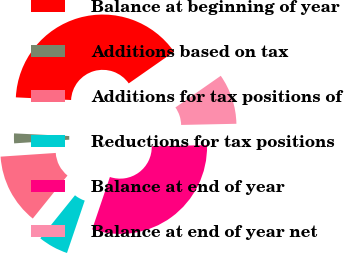Convert chart. <chart><loc_0><loc_0><loc_500><loc_500><pie_chart><fcel>Balance at beginning of year<fcel>Additions based on tax<fcel>Additions for tax positions of<fcel>Reductions for tax positions<fcel>Balance at end of year<fcel>Balance at end of year net<nl><fcel>39.53%<fcel>1.83%<fcel>13.14%<fcel>5.6%<fcel>30.53%<fcel>9.37%<nl></chart> 